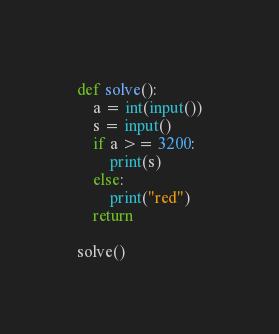Convert code to text. <code><loc_0><loc_0><loc_500><loc_500><_Python_>def solve():
    a = int(input())
    s = input()
    if a >= 3200:
        print(s)
    else:
        print("red")
    return

solve()
</code> 